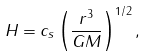<formula> <loc_0><loc_0><loc_500><loc_500>H = c _ { s } \left ( \frac { r ^ { 3 } } { G M } \right ) ^ { 1 / 2 } ,</formula> 